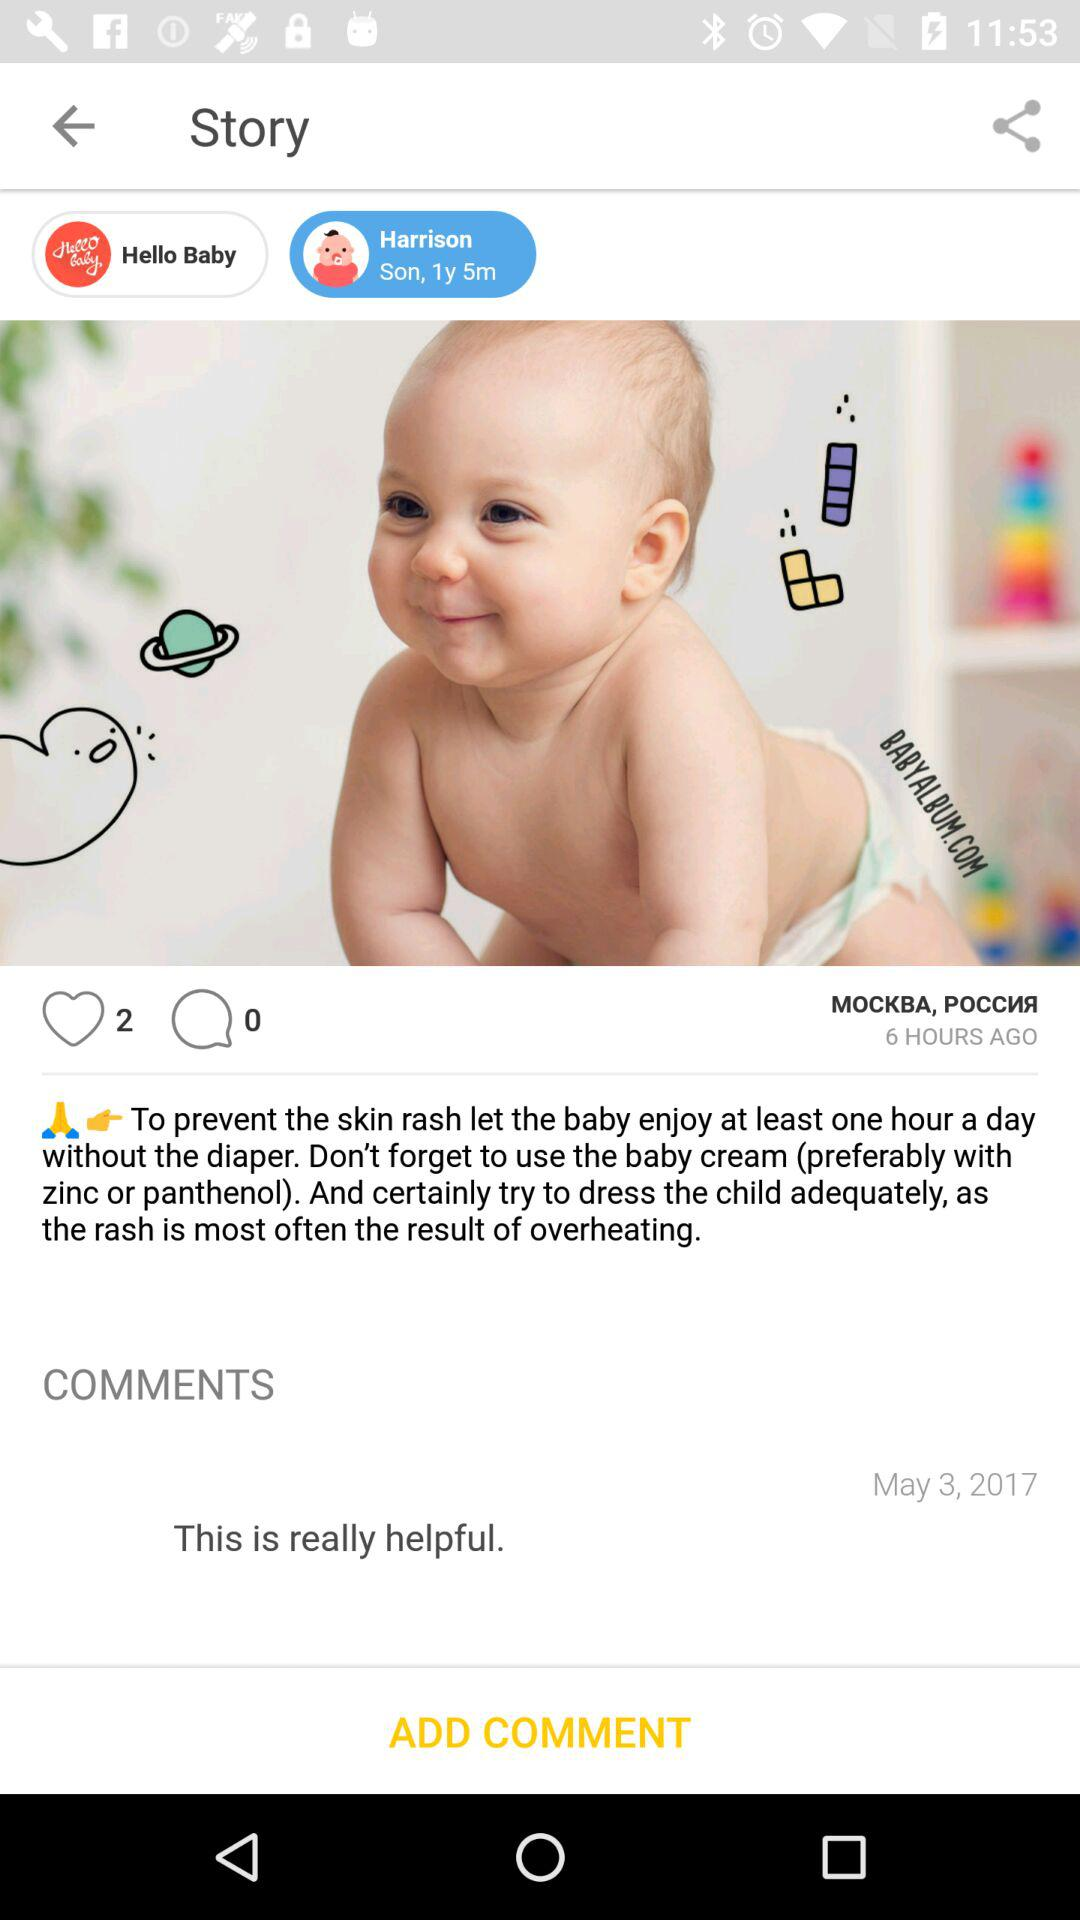What's the name of the baby? The name of the baby is Harrison. 